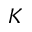<formula> <loc_0><loc_0><loc_500><loc_500>K</formula> 